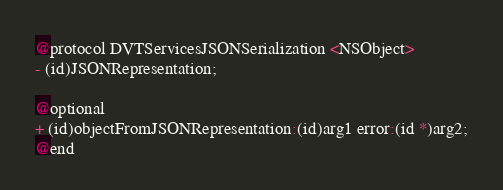<code> <loc_0><loc_0><loc_500><loc_500><_C_>
@protocol DVTServicesJSONSerialization <NSObject>
- (id)JSONRepresentation;

@optional
+ (id)objectFromJSONRepresentation:(id)arg1 error:(id *)arg2;
@end

</code> 